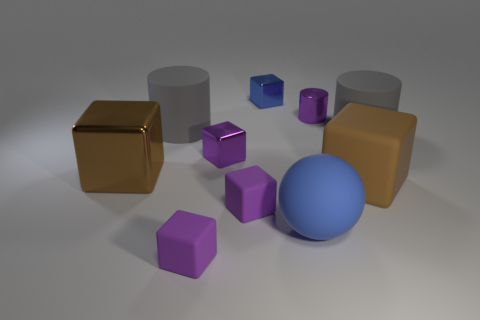There is another large brown object that is the same shape as the big brown metallic thing; what material is it?
Your answer should be compact. Rubber. What number of cubes are rubber things or big gray things?
Give a very brief answer. 3. What number of objects are either cylinders to the right of the big matte ball or purple matte blocks?
Make the answer very short. 4. What is the shape of the big gray thing to the left of the big matte object that is in front of the large brown block in front of the big metallic block?
Your answer should be compact. Cylinder. What number of large rubber objects have the same shape as the blue shiny object?
Provide a succinct answer. 1. There is a small cube that is the same color as the ball; what material is it?
Keep it short and to the point. Metal. Does the big blue object have the same material as the small blue object?
Your answer should be very brief. No. How many purple matte blocks are behind the brown block that is right of the gray matte thing that is on the left side of the brown rubber thing?
Your response must be concise. 0. Is there a blue sphere made of the same material as the tiny blue thing?
Your response must be concise. No. There is a matte block that is the same color as the large shiny thing; what size is it?
Your answer should be compact. Large. 